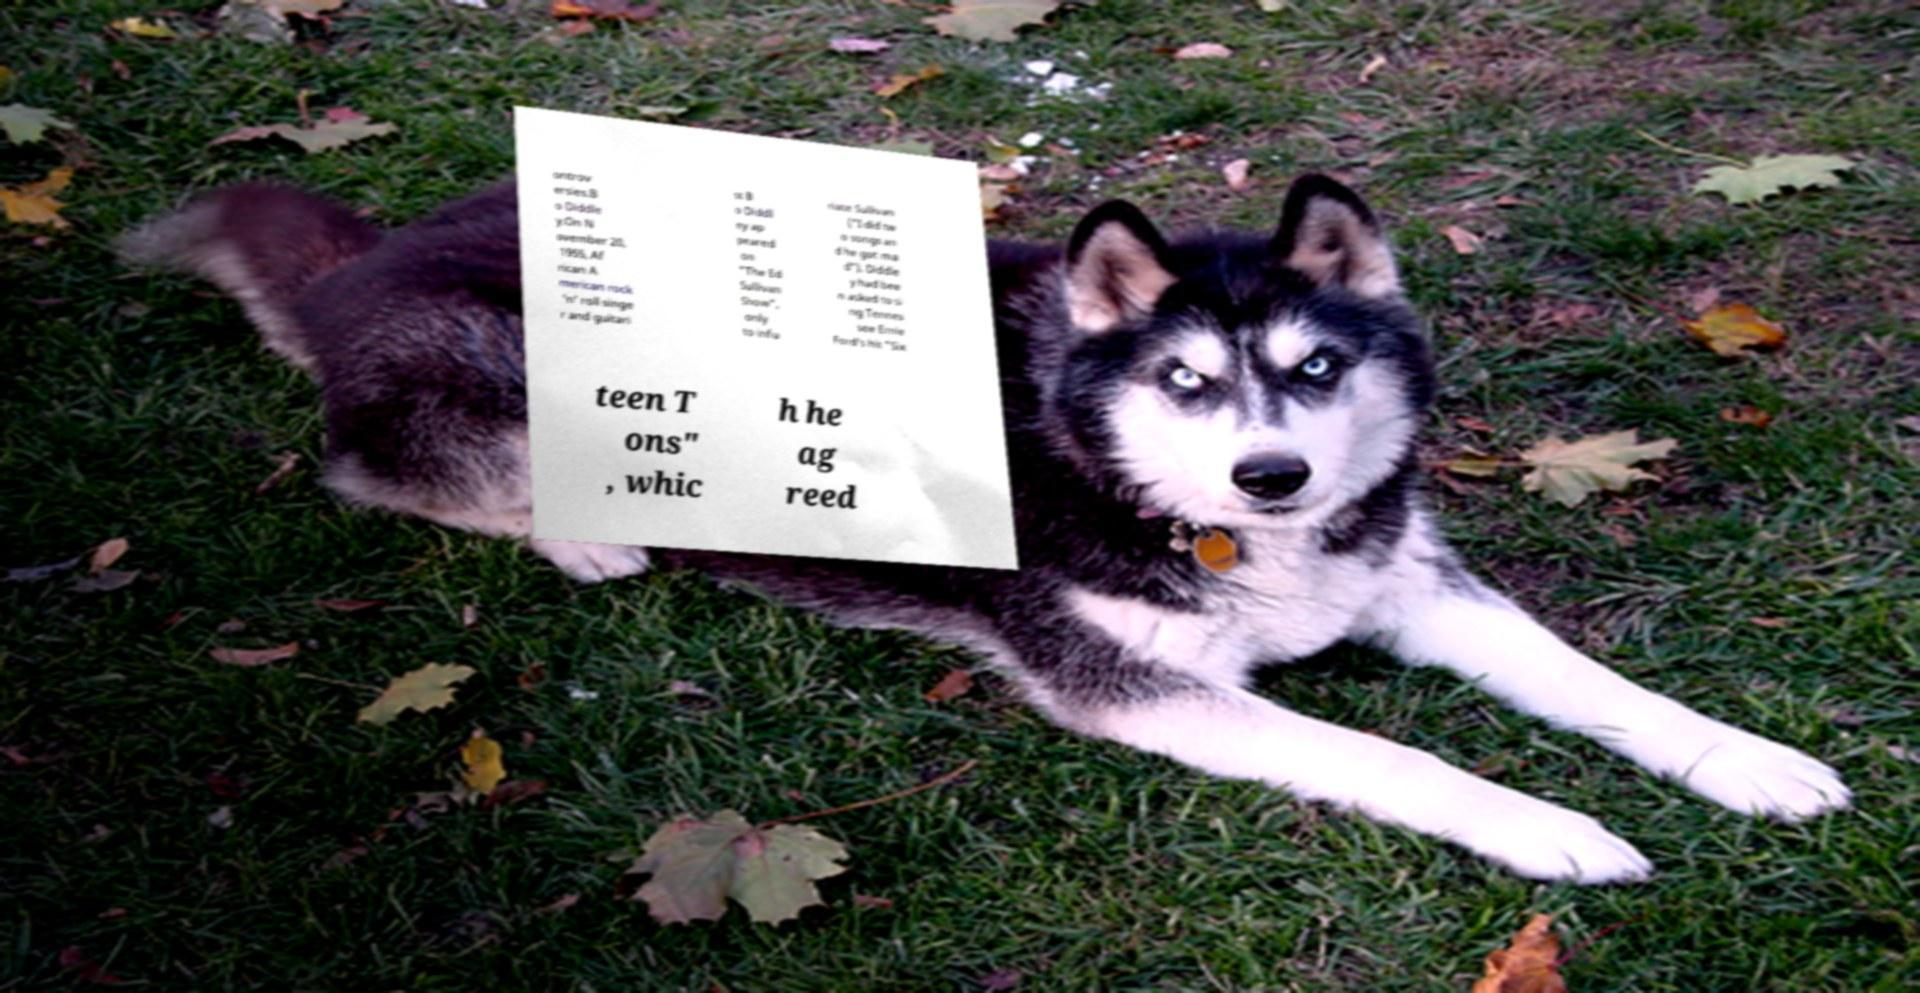There's text embedded in this image that I need extracted. Can you transcribe it verbatim? ontrov ersies.B o Diddle y.On N ovember 20, 1955, Af rican A merican rock 'n' roll singe r and guitari st B o Diddl ey ap peared on "The Ed Sullivan Show", only to infu riate Sullivan ("I did tw o songs an d he got ma d"). Diddle y had bee n asked to si ng Tennes see Ernie Ford's hit "Six teen T ons" , whic h he ag reed 